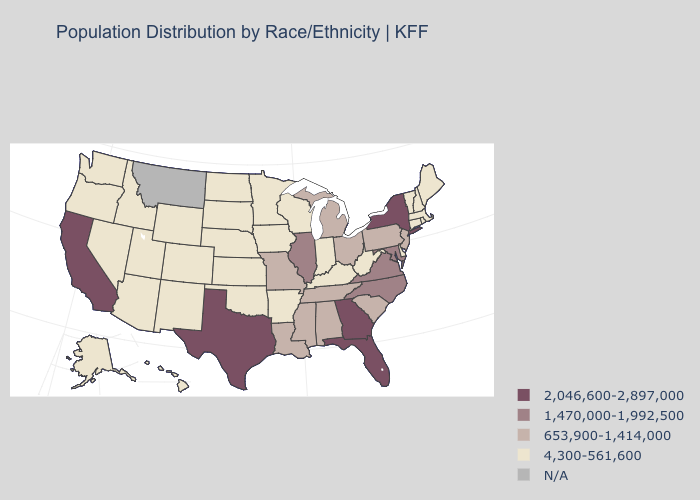Name the states that have a value in the range 653,900-1,414,000?
Answer briefly. Alabama, Louisiana, Michigan, Mississippi, Missouri, New Jersey, Ohio, Pennsylvania, South Carolina, Tennessee. Which states have the lowest value in the USA?
Be succinct. Alaska, Arizona, Arkansas, Colorado, Connecticut, Delaware, Hawaii, Idaho, Indiana, Iowa, Kansas, Kentucky, Maine, Massachusetts, Minnesota, Nebraska, Nevada, New Hampshire, New Mexico, North Dakota, Oklahoma, Oregon, Rhode Island, South Dakota, Utah, Vermont, Washington, West Virginia, Wisconsin, Wyoming. Does the map have missing data?
Short answer required. Yes. Name the states that have a value in the range 4,300-561,600?
Concise answer only. Alaska, Arizona, Arkansas, Colorado, Connecticut, Delaware, Hawaii, Idaho, Indiana, Iowa, Kansas, Kentucky, Maine, Massachusetts, Minnesota, Nebraska, Nevada, New Hampshire, New Mexico, North Dakota, Oklahoma, Oregon, Rhode Island, South Dakota, Utah, Vermont, Washington, West Virginia, Wisconsin, Wyoming. Name the states that have a value in the range 1,470,000-1,992,500?
Quick response, please. Illinois, Maryland, North Carolina, Virginia. Which states have the lowest value in the MidWest?
Short answer required. Indiana, Iowa, Kansas, Minnesota, Nebraska, North Dakota, South Dakota, Wisconsin. Does the map have missing data?
Be succinct. Yes. Which states have the lowest value in the USA?
Be succinct. Alaska, Arizona, Arkansas, Colorado, Connecticut, Delaware, Hawaii, Idaho, Indiana, Iowa, Kansas, Kentucky, Maine, Massachusetts, Minnesota, Nebraska, Nevada, New Hampshire, New Mexico, North Dakota, Oklahoma, Oregon, Rhode Island, South Dakota, Utah, Vermont, Washington, West Virginia, Wisconsin, Wyoming. What is the value of Idaho?
Concise answer only. 4,300-561,600. Name the states that have a value in the range 653,900-1,414,000?
Be succinct. Alabama, Louisiana, Michigan, Mississippi, Missouri, New Jersey, Ohio, Pennsylvania, South Carolina, Tennessee. Name the states that have a value in the range N/A?
Concise answer only. Montana. What is the value of Maryland?
Concise answer only. 1,470,000-1,992,500. How many symbols are there in the legend?
Be succinct. 5. Among the states that border Tennessee , which have the highest value?
Concise answer only. Georgia. What is the value of Wisconsin?
Write a very short answer. 4,300-561,600. 